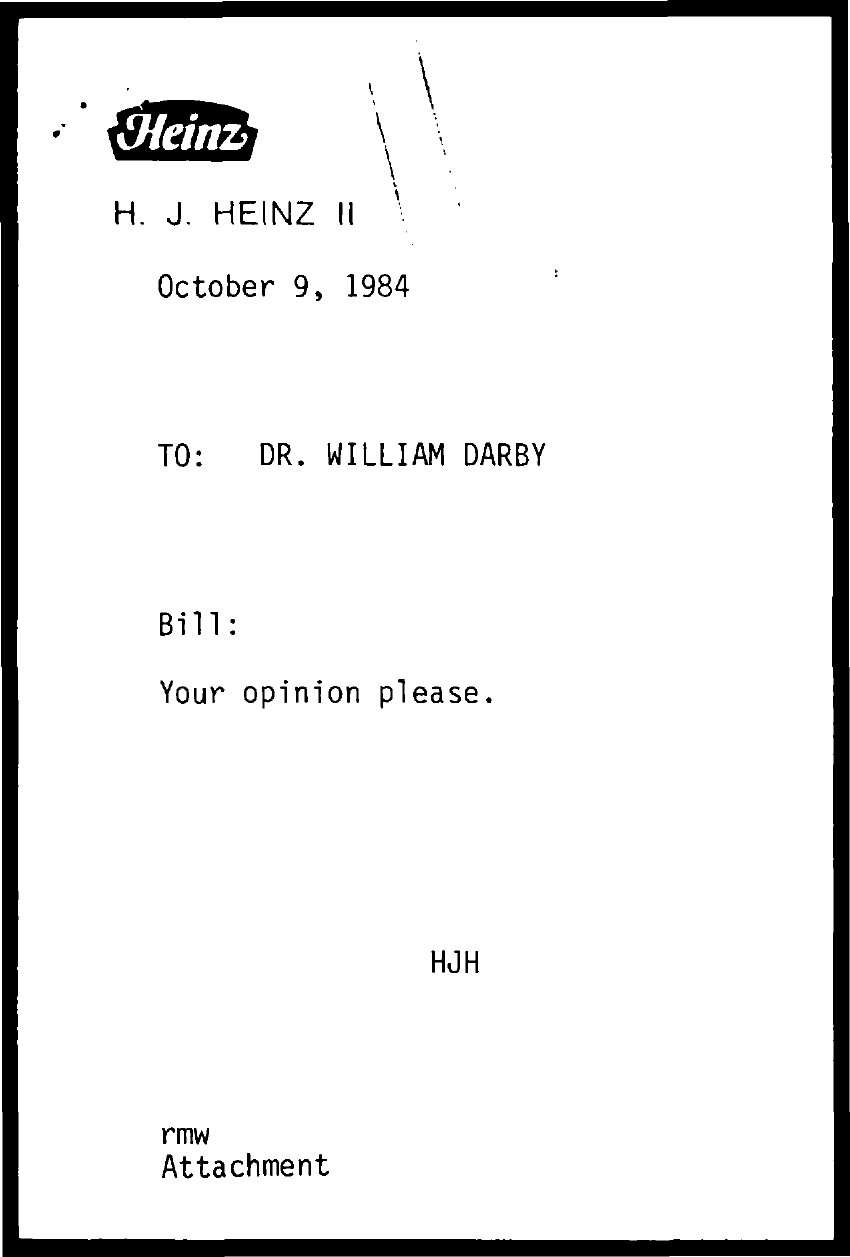Draw attention to some important aspects in this diagram. The name of a company that is mentioned is "Heinz. The document is dated October 9, 1984. The note is addressed to Dr. William Darby. 